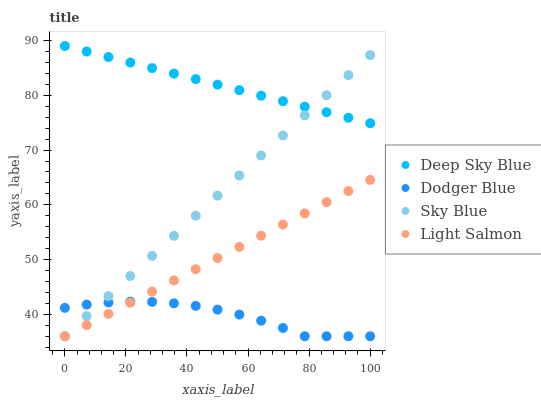Does Dodger Blue have the minimum area under the curve?
Answer yes or no. Yes. Does Deep Sky Blue have the maximum area under the curve?
Answer yes or no. Yes. Does Light Salmon have the minimum area under the curve?
Answer yes or no. No. Does Light Salmon have the maximum area under the curve?
Answer yes or no. No. Is Light Salmon the smoothest?
Answer yes or no. Yes. Is Dodger Blue the roughest?
Answer yes or no. Yes. Is Dodger Blue the smoothest?
Answer yes or no. No. Is Light Salmon the roughest?
Answer yes or no. No. Does Sky Blue have the lowest value?
Answer yes or no. Yes. Does Deep Sky Blue have the lowest value?
Answer yes or no. No. Does Deep Sky Blue have the highest value?
Answer yes or no. Yes. Does Light Salmon have the highest value?
Answer yes or no. No. Is Light Salmon less than Deep Sky Blue?
Answer yes or no. Yes. Is Deep Sky Blue greater than Dodger Blue?
Answer yes or no. Yes. Does Sky Blue intersect Dodger Blue?
Answer yes or no. Yes. Is Sky Blue less than Dodger Blue?
Answer yes or no. No. Is Sky Blue greater than Dodger Blue?
Answer yes or no. No. Does Light Salmon intersect Deep Sky Blue?
Answer yes or no. No. 